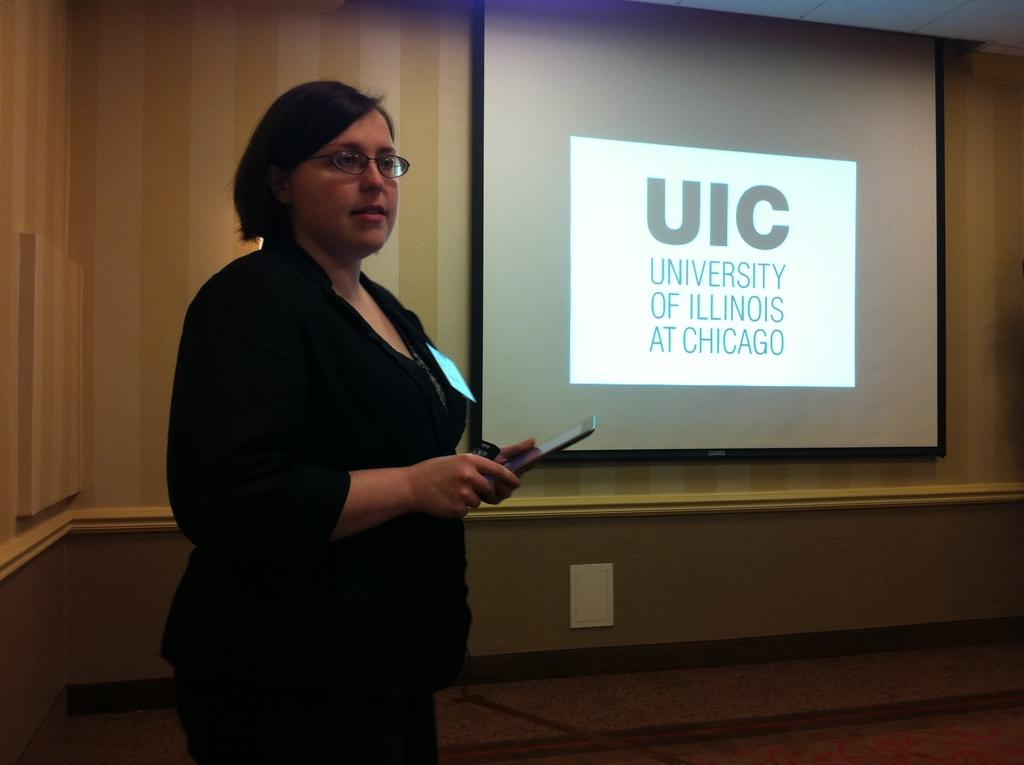Who is present in the image? There is a woman in the image. What is the woman wearing? The woman is wearing a black dress. What can be seen on the right side of the image? There is a projector screen on the right side of the image. What is visible in the background of the image? There is a wall in the background of the image. What is the surface on which the scene is taking place? There is a floor at the bottom of the image. What type of drink is the woman holding in the image? There is no drink visible in the image; the woman is not holding anything. 